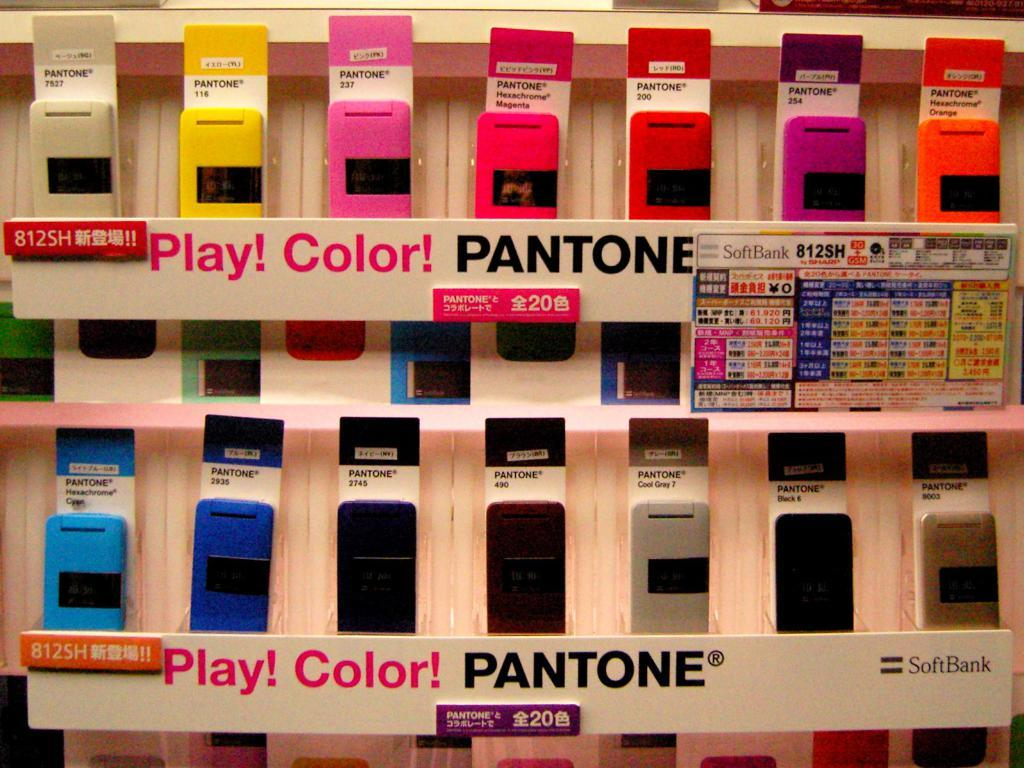<image>
Present a compact description of the photo's key features. Various strips of different colors of paint are on shelves for the brand Pantone. 